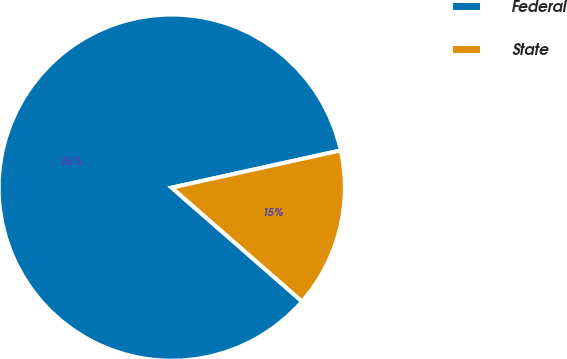Convert chart to OTSL. <chart><loc_0><loc_0><loc_500><loc_500><pie_chart><fcel>Federal<fcel>State<nl><fcel>85.12%<fcel>14.88%<nl></chart> 